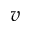<formula> <loc_0><loc_0><loc_500><loc_500>v</formula> 